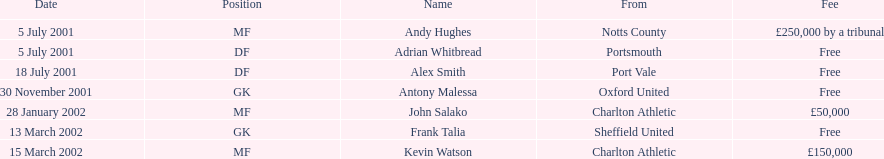Andy huges and adrian whitbread both switched on what date? 5 July 2001. 